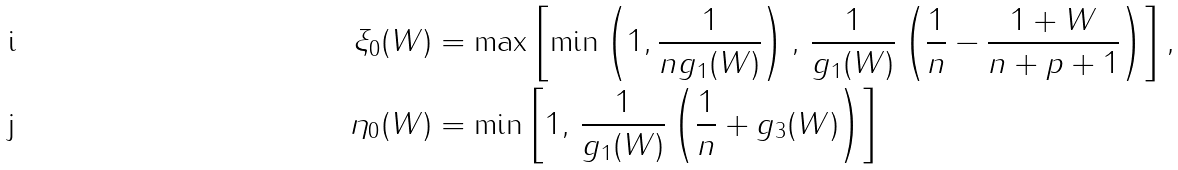Convert formula to latex. <formula><loc_0><loc_0><loc_500><loc_500>\xi _ { 0 } ( W ) & = \max \left [ \min \left ( 1 , \frac { 1 } { n g _ { 1 } ( W ) } \right ) , \, \frac { 1 } { g _ { 1 } ( W ) } \left ( \frac { 1 } { n } - \frac { 1 + W } { n + p + 1 } \right ) \right ] , \\ \eta _ { 0 } ( W ) & = \min \left [ 1 , \, \frac { 1 } { g _ { 1 } ( W ) } \left ( \frac { 1 } { n } + g _ { 3 } ( W ) \right ) \right ]</formula> 